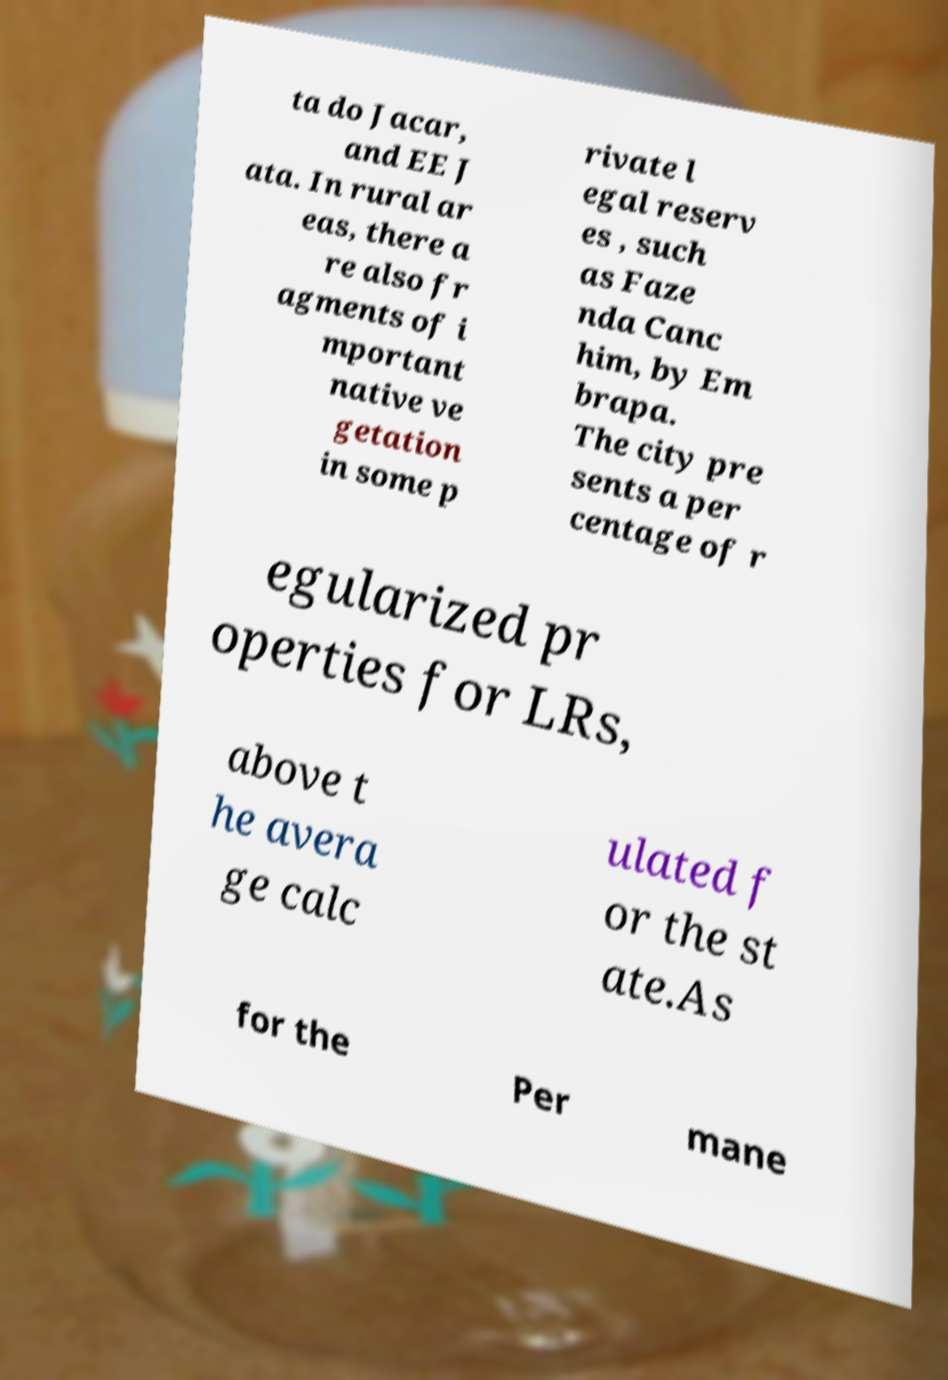What messages or text are displayed in this image? I need them in a readable, typed format. ta do Jacar, and EE J ata. In rural ar eas, there a re also fr agments of i mportant native ve getation in some p rivate l egal reserv es , such as Faze nda Canc him, by Em brapa. The city pre sents a per centage of r egularized pr operties for LRs, above t he avera ge calc ulated f or the st ate.As for the Per mane 